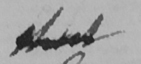Please transcribe the handwritten text in this image. that 